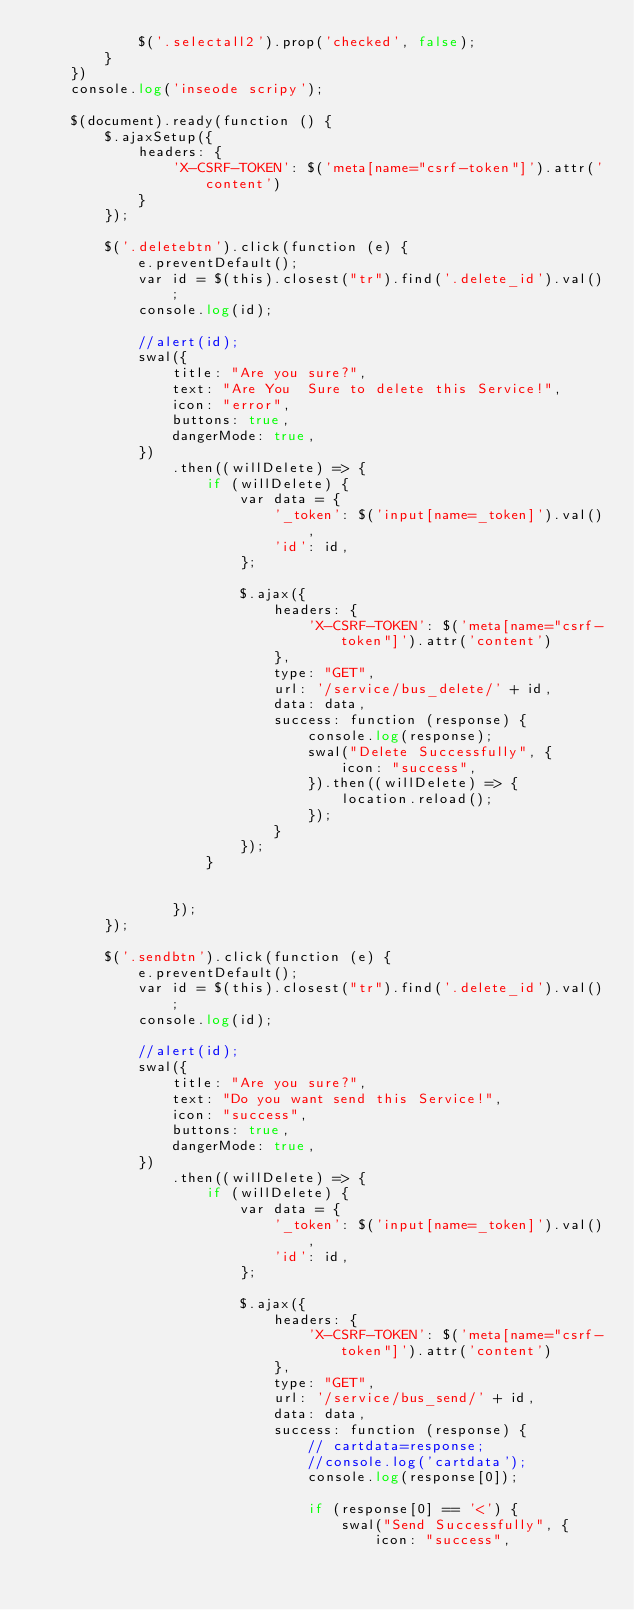Convert code to text. <code><loc_0><loc_0><loc_500><loc_500><_PHP_>            $('.selectall2').prop('checked', false);
        }
    })
    console.log('inseode scripy');

    $(document).ready(function () {
        $.ajaxSetup({
            headers: {
                'X-CSRF-TOKEN': $('meta[name="csrf-token"]').attr('content')
            }
        });

        $('.deletebtn').click(function (e) {
            e.preventDefault();
            var id = $(this).closest("tr").find('.delete_id').val();
            console.log(id);

            //alert(id);
            swal({
                title: "Are you sure?",
                text: "Are You  Sure to delete this Service!",
                icon: "error",
                buttons: true,
                dangerMode: true,
            })
                .then((willDelete) => {
                    if (willDelete) {
                        var data = {
                            '_token': $('input[name=_token]').val(),
                            'id': id,
                        };

                        $.ajax({
                            headers: {
                                'X-CSRF-TOKEN': $('meta[name="csrf-token"]').attr('content')
                            },
                            type: "GET",
                            url: '/service/bus_delete/' + id,
                            data: data,
                            success: function (response) {
                                console.log(response);
                                swal("Delete Successfully", {
                                    icon: "success",
                                }).then((willDelete) => {
                                    location.reload();
                                });
                            }
                        });
                    }


                });
        });

        $('.sendbtn').click(function (e) {
            e.preventDefault();
            var id = $(this).closest("tr").find('.delete_id').val();
            console.log(id);

            //alert(id);
            swal({
                title: "Are you sure?",
                text: "Do you want send this Service!",
                icon: "success",
                buttons: true,
                dangerMode: true,
            })
                .then((willDelete) => {
                    if (willDelete) {
                        var data = {
                            '_token': $('input[name=_token]').val(),
                            'id': id,
                        };

                        $.ajax({
                            headers: {
                                'X-CSRF-TOKEN': $('meta[name="csrf-token"]').attr('content')
                            },
                            type: "GET",
                            url: '/service/bus_send/' + id,
                            data: data,
                            success: function (response) {
                                // cartdata=response;
                                //console.log('cartdata');
                                console.log(response[0]);

                                if (response[0] == '<') {
                                    swal("Send Successfully", {
                                        icon: "success",</code> 